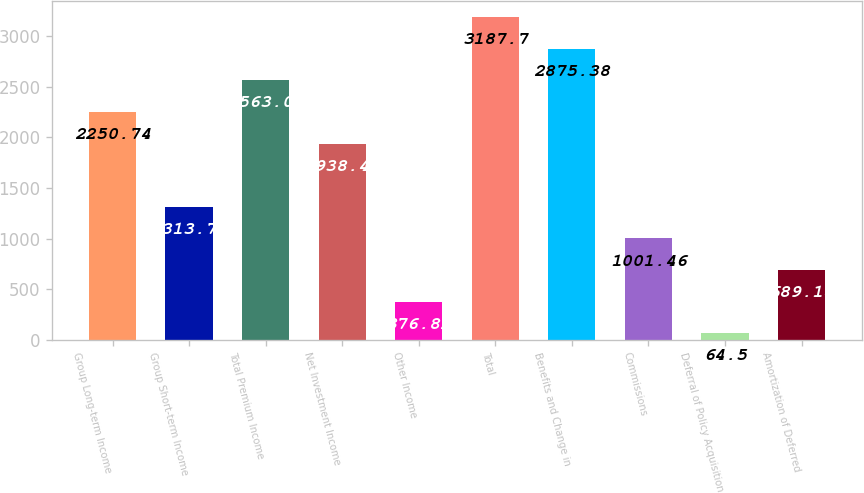<chart> <loc_0><loc_0><loc_500><loc_500><bar_chart><fcel>Group Long-term Income<fcel>Group Short-term Income<fcel>Total Premium Income<fcel>Net Investment Income<fcel>Other Income<fcel>Total<fcel>Benefits and Change in<fcel>Commissions<fcel>Deferral of Policy Acquisition<fcel>Amortization of Deferred<nl><fcel>2250.74<fcel>1313.78<fcel>2563.06<fcel>1938.42<fcel>376.82<fcel>3187.7<fcel>2875.38<fcel>1001.46<fcel>64.5<fcel>689.14<nl></chart> 